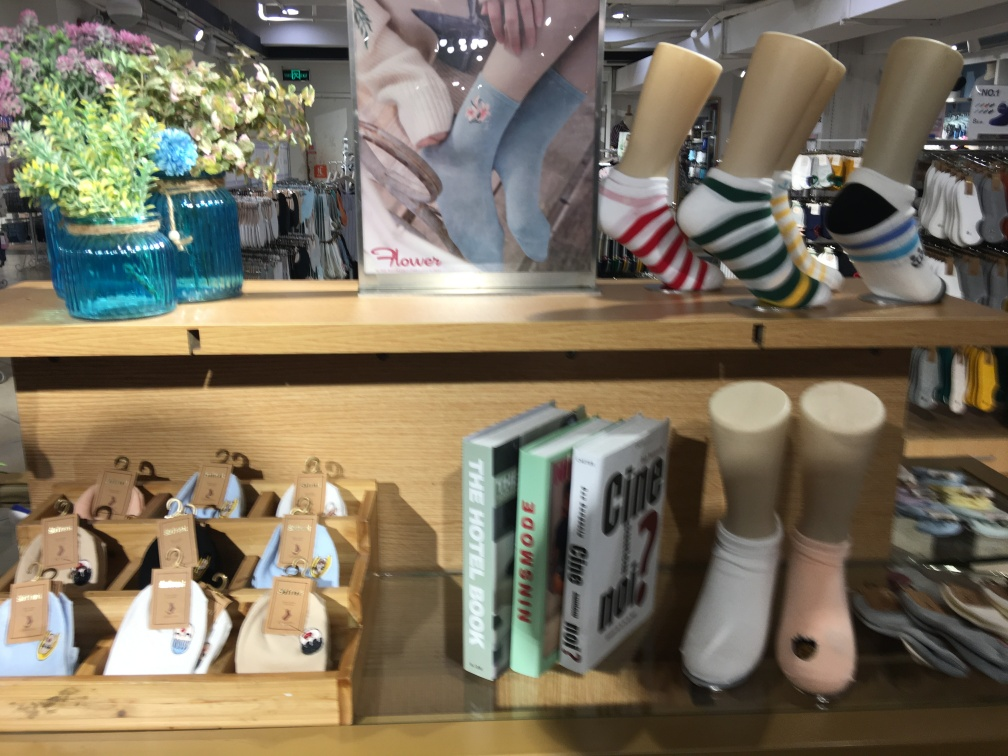Can you tell me more about the books on the shelf? Certainly! There are several books on the shelf with covers suggesting they might be related to style and travel. One has a title that includes the word 'CITIES', and another is labeled 'THE HOTEL BOOK', indicating a focus on urban exploration and unique accommodations. 